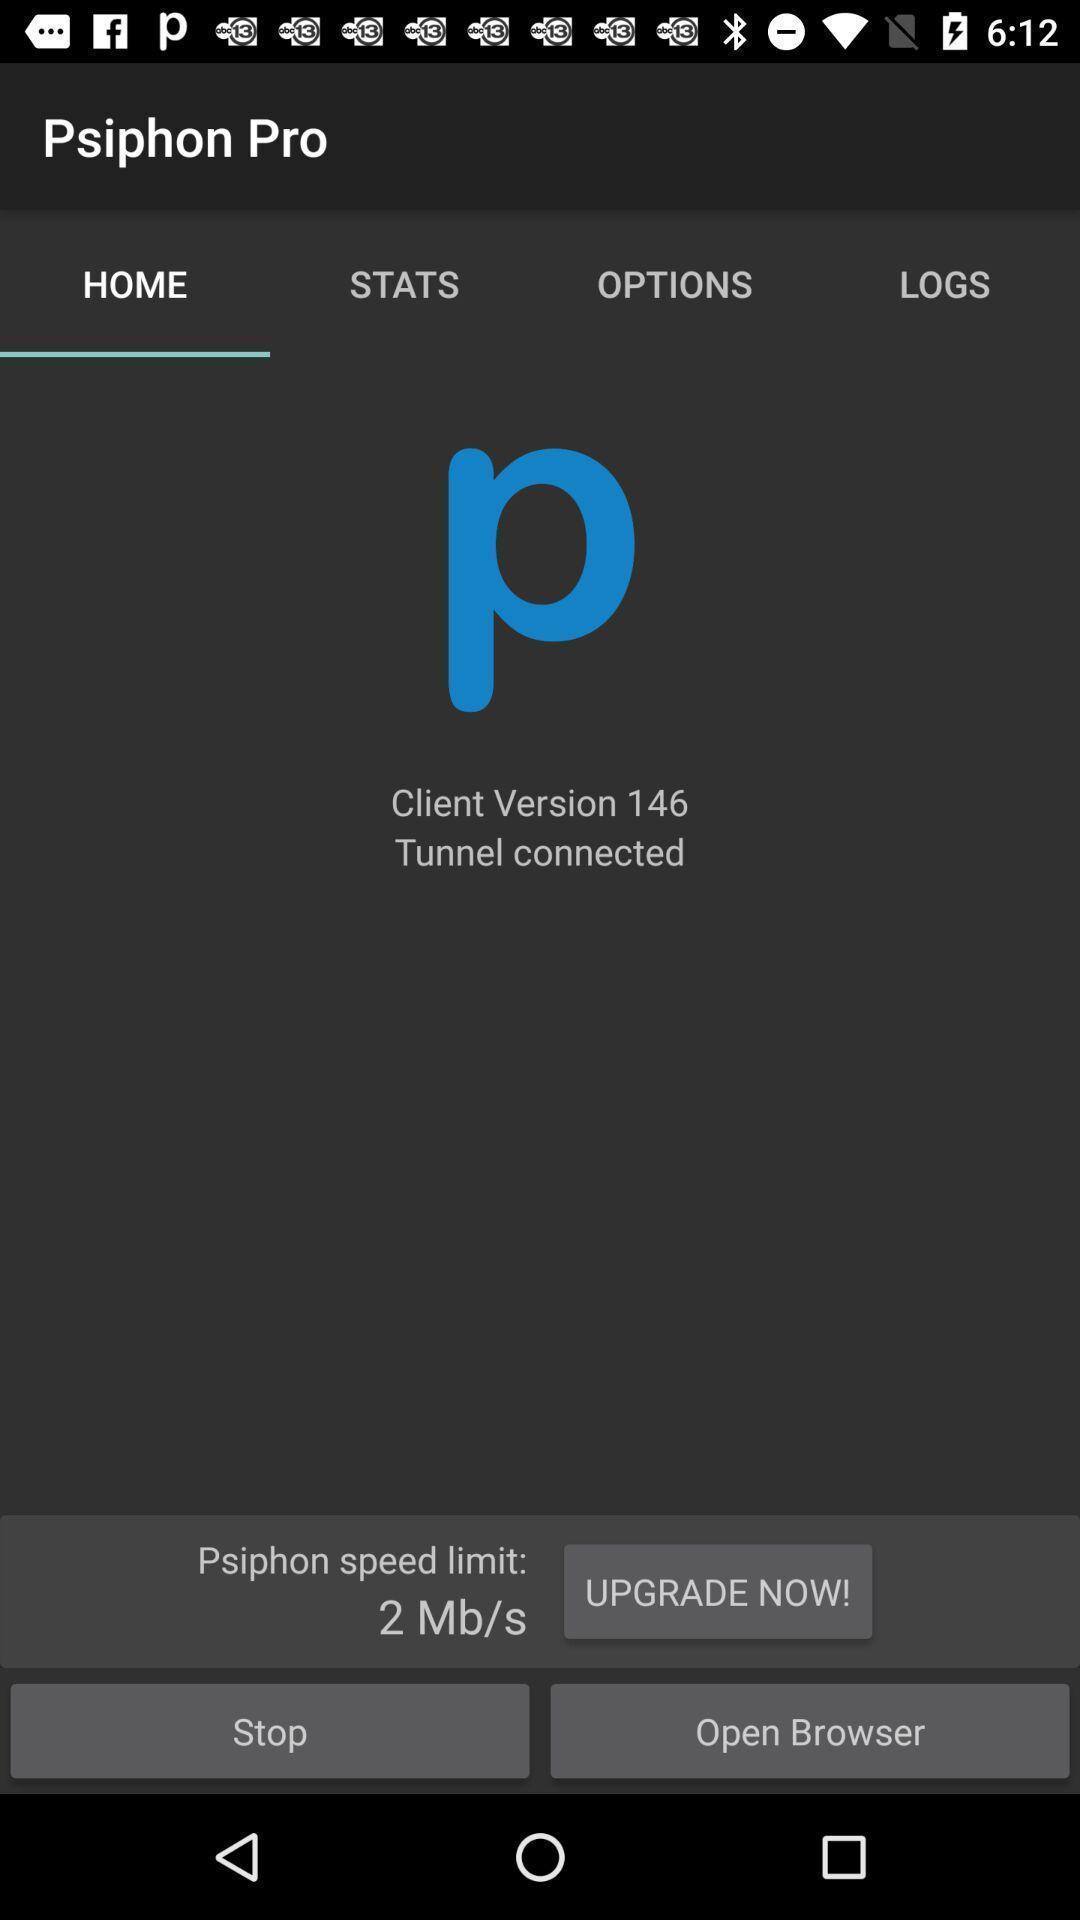Explain the elements present in this screenshot. Screen displaying home page. 